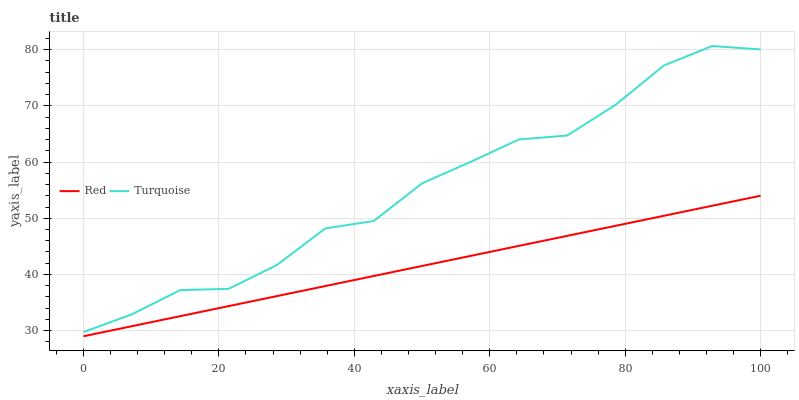Does Red have the minimum area under the curve?
Answer yes or no. Yes. Does Turquoise have the maximum area under the curve?
Answer yes or no. Yes. Does Red have the maximum area under the curve?
Answer yes or no. No. Is Red the smoothest?
Answer yes or no. Yes. Is Turquoise the roughest?
Answer yes or no. Yes. Is Red the roughest?
Answer yes or no. No. Does Red have the lowest value?
Answer yes or no. Yes. Does Turquoise have the highest value?
Answer yes or no. Yes. Does Red have the highest value?
Answer yes or no. No. Is Red less than Turquoise?
Answer yes or no. Yes. Is Turquoise greater than Red?
Answer yes or no. Yes. Does Red intersect Turquoise?
Answer yes or no. No. 